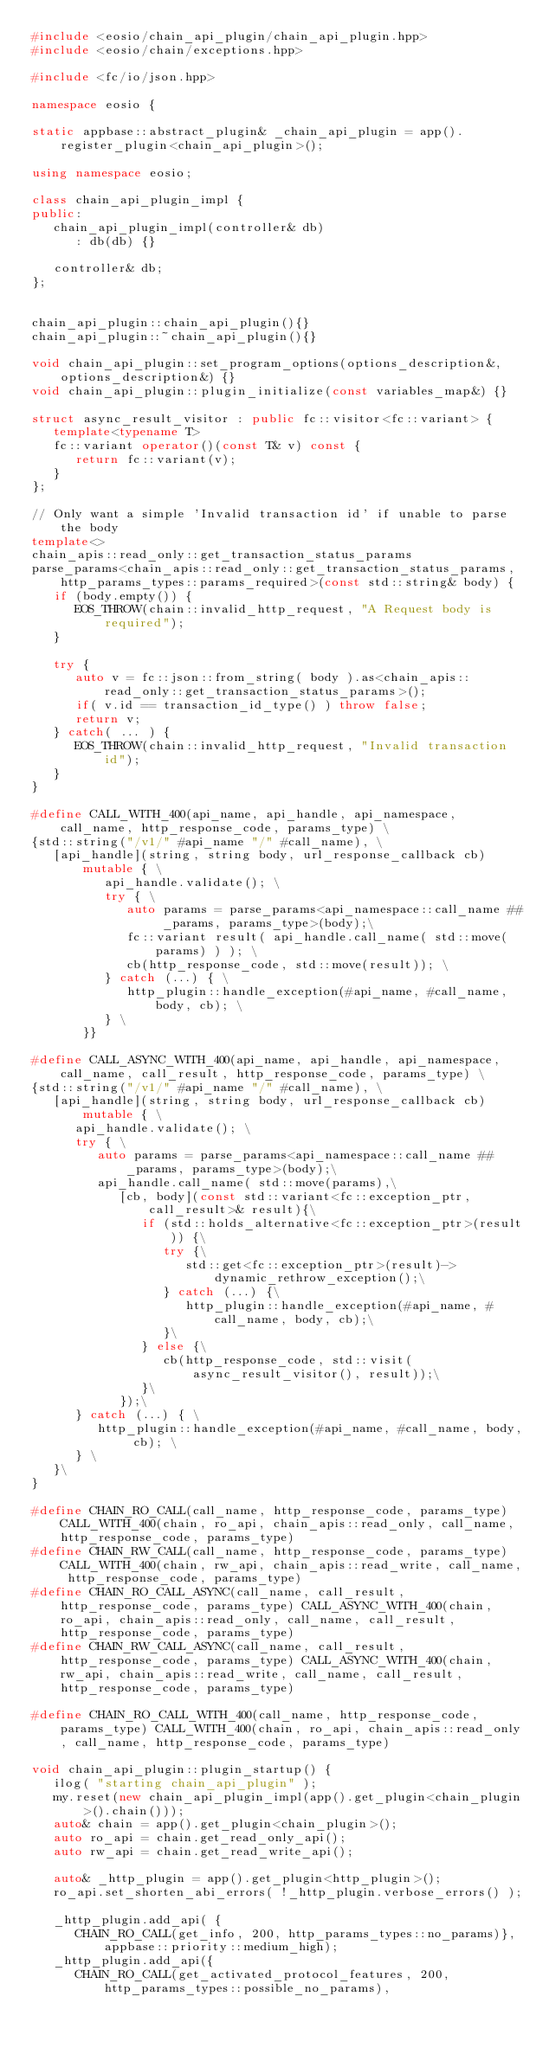<code> <loc_0><loc_0><loc_500><loc_500><_C++_>#include <eosio/chain_api_plugin/chain_api_plugin.hpp>
#include <eosio/chain/exceptions.hpp>

#include <fc/io/json.hpp>

namespace eosio {

static appbase::abstract_plugin& _chain_api_plugin = app().register_plugin<chain_api_plugin>();

using namespace eosio;

class chain_api_plugin_impl {
public:
   chain_api_plugin_impl(controller& db)
      : db(db) {}

   controller& db;
};


chain_api_plugin::chain_api_plugin(){}
chain_api_plugin::~chain_api_plugin(){}

void chain_api_plugin::set_program_options(options_description&, options_description&) {}
void chain_api_plugin::plugin_initialize(const variables_map&) {}

struct async_result_visitor : public fc::visitor<fc::variant> {
   template<typename T>
   fc::variant operator()(const T& v) const {
      return fc::variant(v);
   }
};

// Only want a simple 'Invalid transaction id' if unable to parse the body
template<>
chain_apis::read_only::get_transaction_status_params
parse_params<chain_apis::read_only::get_transaction_status_params, http_params_types::params_required>(const std::string& body) {
   if (body.empty()) {
      EOS_THROW(chain::invalid_http_request, "A Request body is required");
   }

   try {
      auto v = fc::json::from_string( body ).as<chain_apis::read_only::get_transaction_status_params>();
      if( v.id == transaction_id_type() ) throw false;
      return v;
   } catch( ... ) {
      EOS_THROW(chain::invalid_http_request, "Invalid transaction id");
   }
}

#define CALL_WITH_400(api_name, api_handle, api_namespace, call_name, http_response_code, params_type) \
{std::string("/v1/" #api_name "/" #call_name), \
   [api_handle](string, string body, url_response_callback cb) mutable { \
          api_handle.validate(); \
          try { \
             auto params = parse_params<api_namespace::call_name ## _params, params_type>(body);\
             fc::variant result( api_handle.call_name( std::move(params) ) ); \
             cb(http_response_code, std::move(result)); \
          } catch (...) { \
             http_plugin::handle_exception(#api_name, #call_name, body, cb); \
          } \
       }}

#define CALL_ASYNC_WITH_400(api_name, api_handle, api_namespace, call_name, call_result, http_response_code, params_type) \
{std::string("/v1/" #api_name "/" #call_name), \
   [api_handle](string, string body, url_response_callback cb) mutable { \
      api_handle.validate(); \
      try { \
         auto params = parse_params<api_namespace::call_name ## _params, params_type>(body);\
         api_handle.call_name( std::move(params),\
            [cb, body](const std::variant<fc::exception_ptr, call_result>& result){\
               if (std::holds_alternative<fc::exception_ptr>(result)) {\
                  try {\
                     std::get<fc::exception_ptr>(result)->dynamic_rethrow_exception();\
                  } catch (...) {\
                     http_plugin::handle_exception(#api_name, #call_name, body, cb);\
                  }\
               } else {\
                  cb(http_response_code, std::visit(async_result_visitor(), result));\
               }\
            });\
      } catch (...) { \
         http_plugin::handle_exception(#api_name, #call_name, body, cb); \
      } \
   }\
}

#define CHAIN_RO_CALL(call_name, http_response_code, params_type) CALL_WITH_400(chain, ro_api, chain_apis::read_only, call_name, http_response_code, params_type)
#define CHAIN_RW_CALL(call_name, http_response_code, params_type) CALL_WITH_400(chain, rw_api, chain_apis::read_write, call_name, http_response_code, params_type)
#define CHAIN_RO_CALL_ASYNC(call_name, call_result, http_response_code, params_type) CALL_ASYNC_WITH_400(chain, ro_api, chain_apis::read_only, call_name, call_result, http_response_code, params_type)
#define CHAIN_RW_CALL_ASYNC(call_name, call_result, http_response_code, params_type) CALL_ASYNC_WITH_400(chain, rw_api, chain_apis::read_write, call_name, call_result, http_response_code, params_type)

#define CHAIN_RO_CALL_WITH_400(call_name, http_response_code, params_type) CALL_WITH_400(chain, ro_api, chain_apis::read_only, call_name, http_response_code, params_type)

void chain_api_plugin::plugin_startup() {
   ilog( "starting chain_api_plugin" );
   my.reset(new chain_api_plugin_impl(app().get_plugin<chain_plugin>().chain()));
   auto& chain = app().get_plugin<chain_plugin>();
   auto ro_api = chain.get_read_only_api();
   auto rw_api = chain.get_read_write_api();

   auto& _http_plugin = app().get_plugin<http_plugin>();
   ro_api.set_shorten_abi_errors( !_http_plugin.verbose_errors() );

   _http_plugin.add_api( {
      CHAIN_RO_CALL(get_info, 200, http_params_types::no_params)}, appbase::priority::medium_high);
   _http_plugin.add_api({
      CHAIN_RO_CALL(get_activated_protocol_features, 200, http_params_types::possible_no_params),</code> 